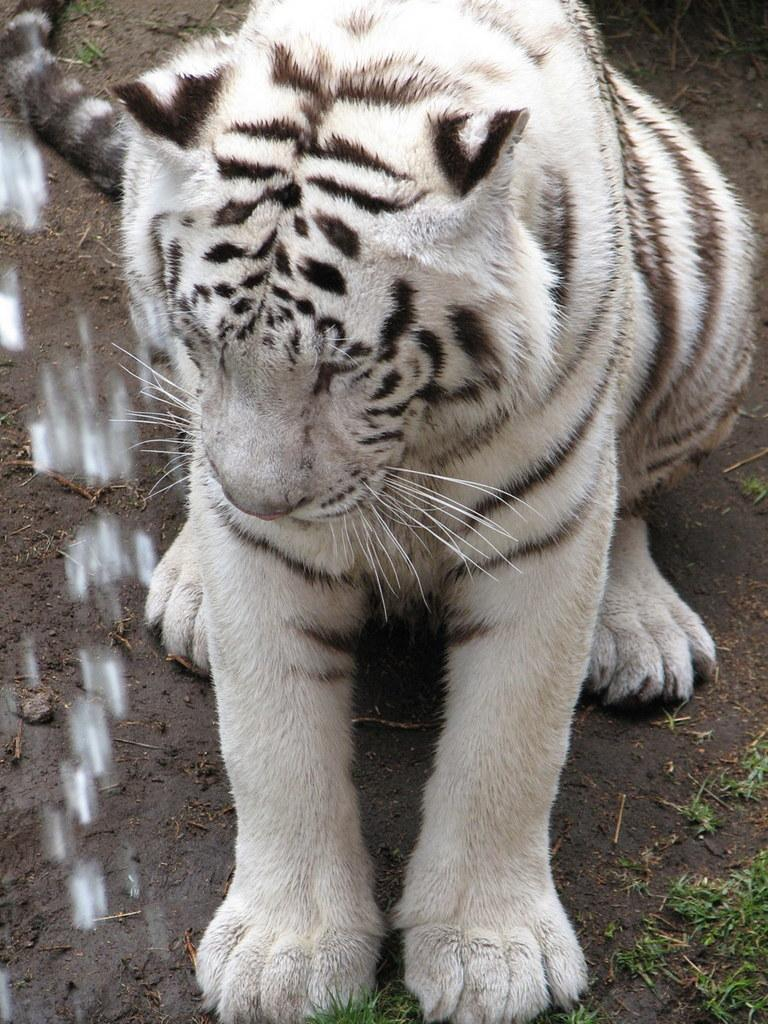What type of animal is in the image? There is a Bengal tiger in the image. Where is the Bengal tiger located in the image? The Bengal tiger is in the front of the image. What type of vegetation is at the bottom of the image? There is grass at the bottom of the image. What type of ground is present at the bottom of the image? Soil is present at the bottom of the image. How many brothers does the Bengal tiger have in the image? There is no information about the Bengal tiger's brothers in the image. What type of needle is being used by the Bengal tiger in the image? There is no needle present in the image. 